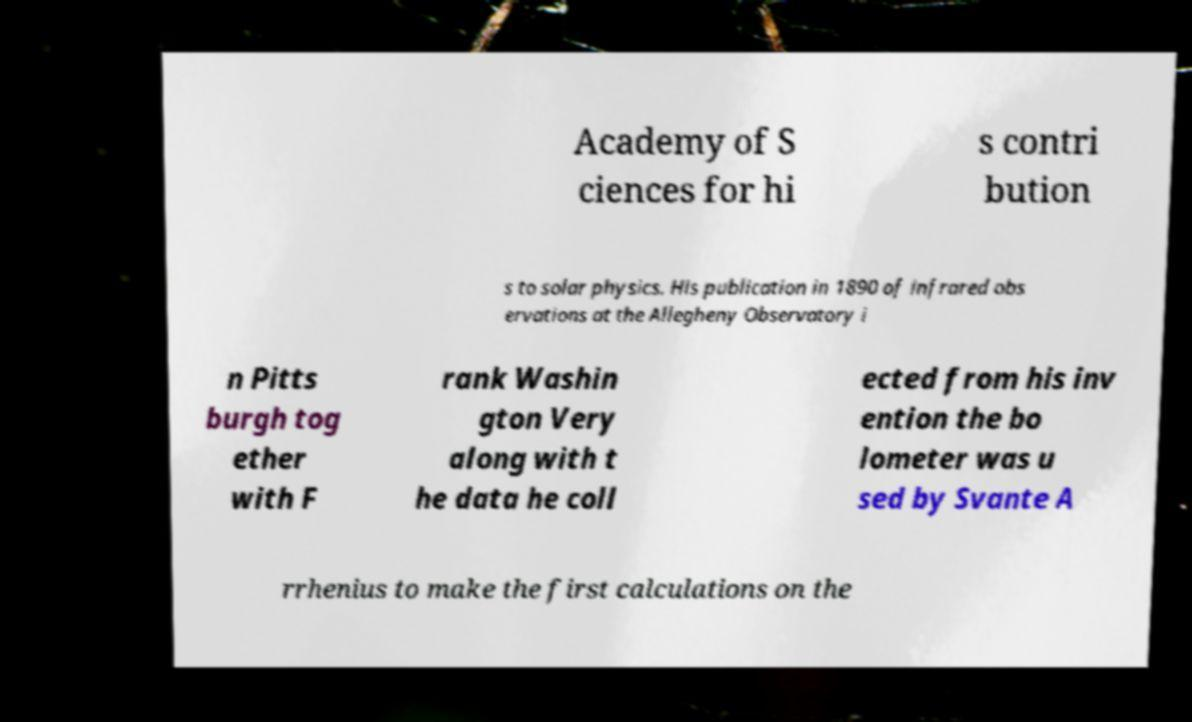Please read and relay the text visible in this image. What does it say? Academy of S ciences for hi s contri bution s to solar physics. His publication in 1890 of infrared obs ervations at the Allegheny Observatory i n Pitts burgh tog ether with F rank Washin gton Very along with t he data he coll ected from his inv ention the bo lometer was u sed by Svante A rrhenius to make the first calculations on the 